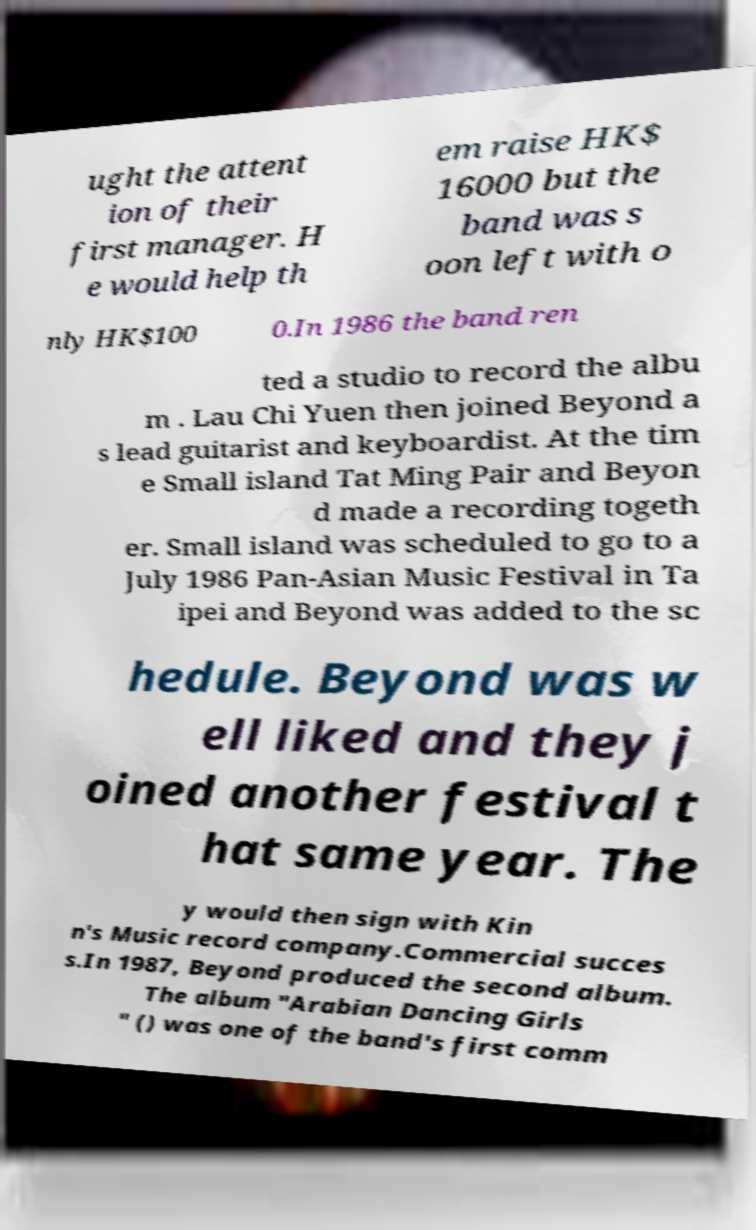Can you accurately transcribe the text from the provided image for me? ught the attent ion of their first manager. H e would help th em raise HK$ 16000 but the band was s oon left with o nly HK$100 0.In 1986 the band ren ted a studio to record the albu m . Lau Chi Yuen then joined Beyond a s lead guitarist and keyboardist. At the tim e Small island Tat Ming Pair and Beyon d made a recording togeth er. Small island was scheduled to go to a July 1986 Pan-Asian Music Festival in Ta ipei and Beyond was added to the sc hedule. Beyond was w ell liked and they j oined another festival t hat same year. The y would then sign with Kin n's Music record company.Commercial succes s.In 1987, Beyond produced the second album. The album "Arabian Dancing Girls " () was one of the band's first comm 